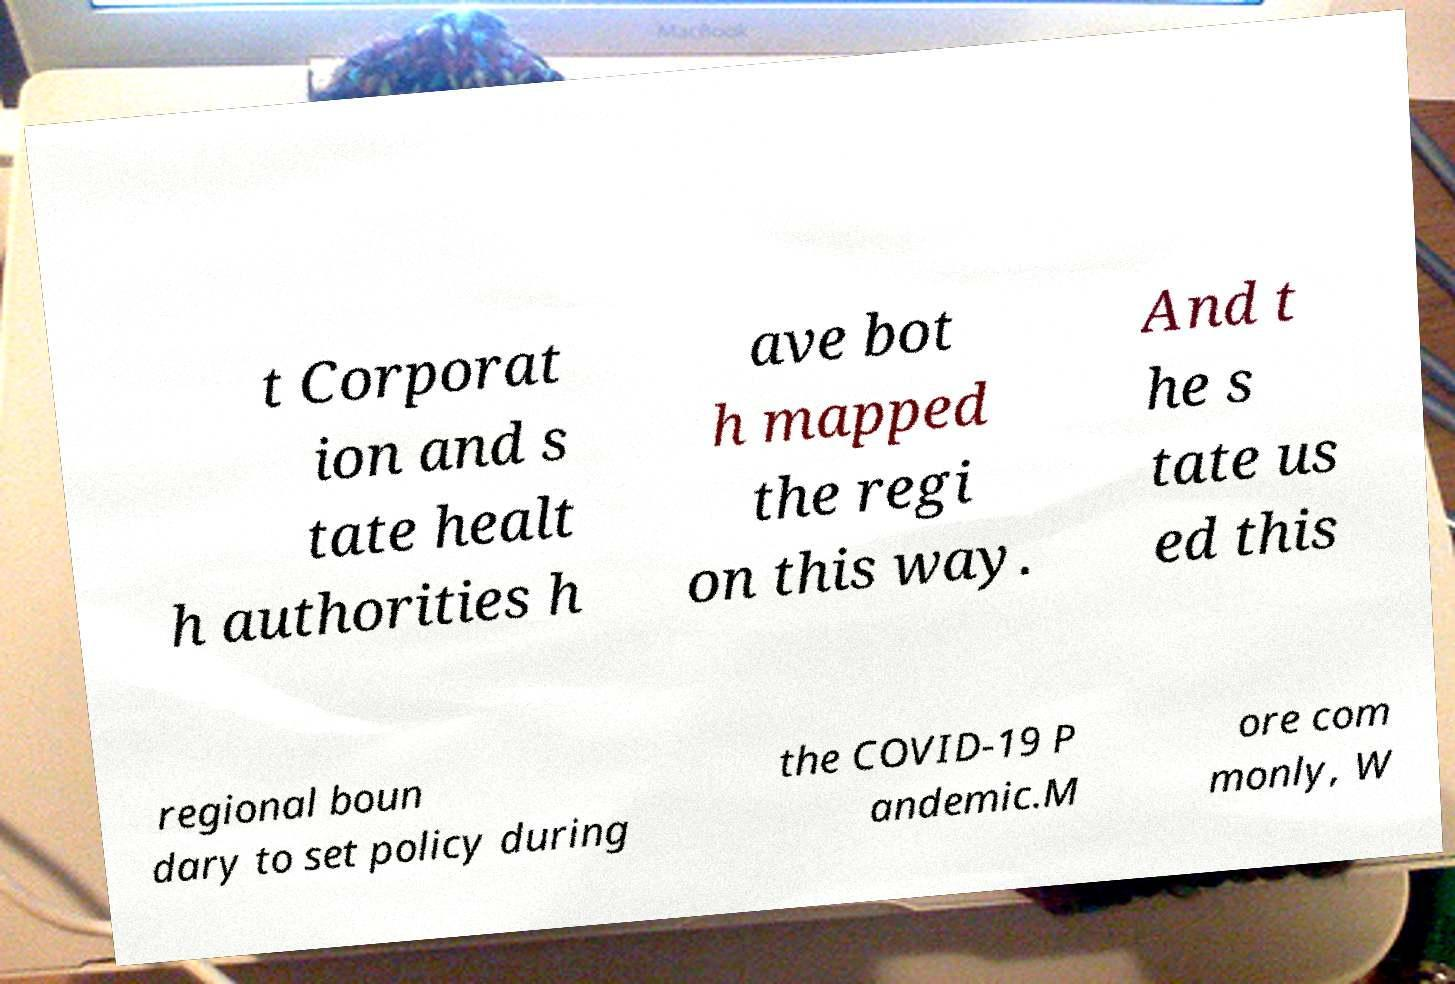Could you assist in decoding the text presented in this image and type it out clearly? t Corporat ion and s tate healt h authorities h ave bot h mapped the regi on this way. And t he s tate us ed this regional boun dary to set policy during the COVID-19 P andemic.M ore com monly, W 